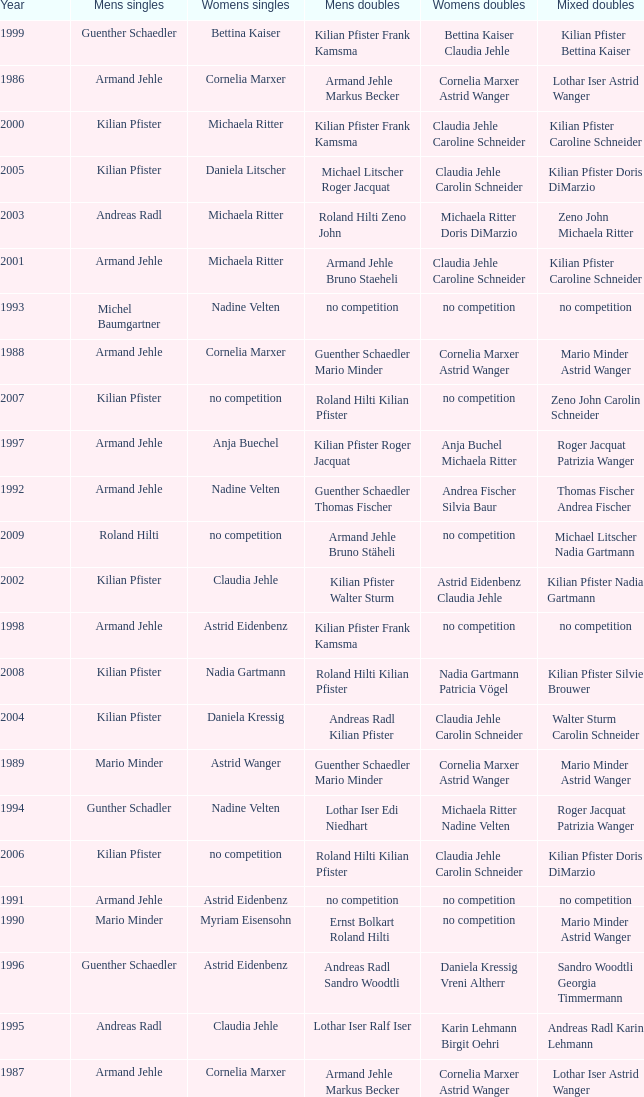What is the most current year where the women's doubles champions are astrid eidenbenz claudia jehle 2002.0. 